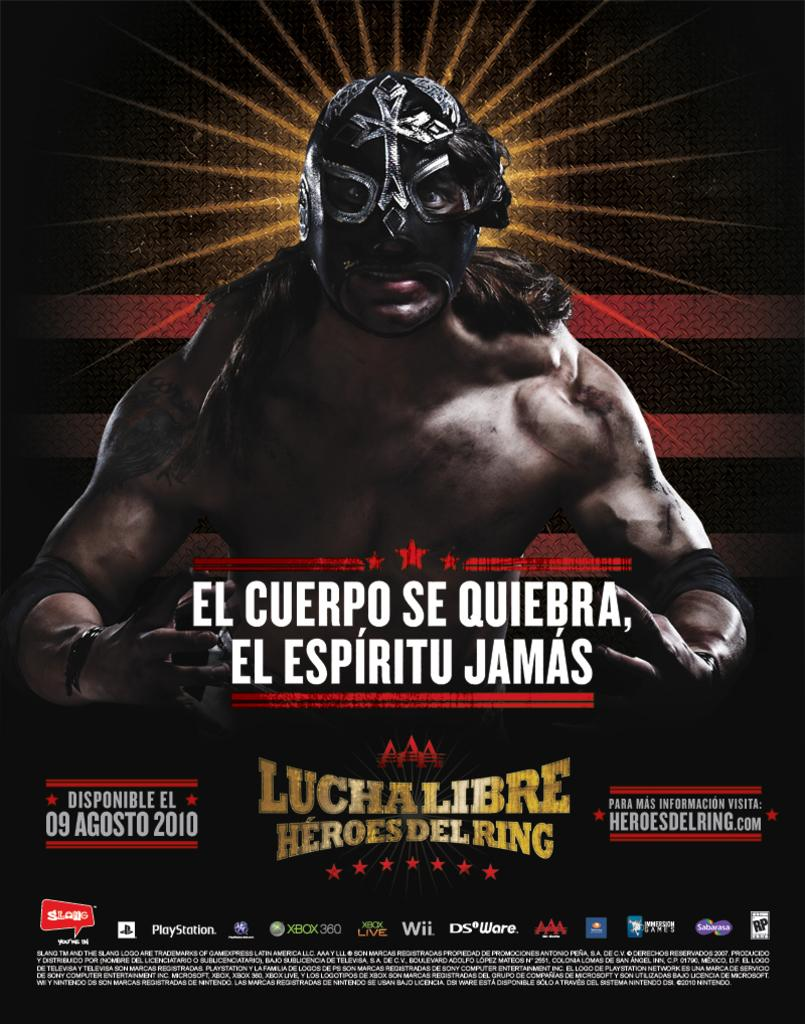What type of visual is the image? The image is a poster. What is depicted on the poster? There is a person with a mask on the poster. What else can be found on the poster besides the person with a mask? There are words, symbols, and icons on the poster. Can you see a toad hopping on the poster? There is no toad present on the poster. What rule is being enforced by the person with a mask on the poster? The image does not provide any information about a rule being enforced. 